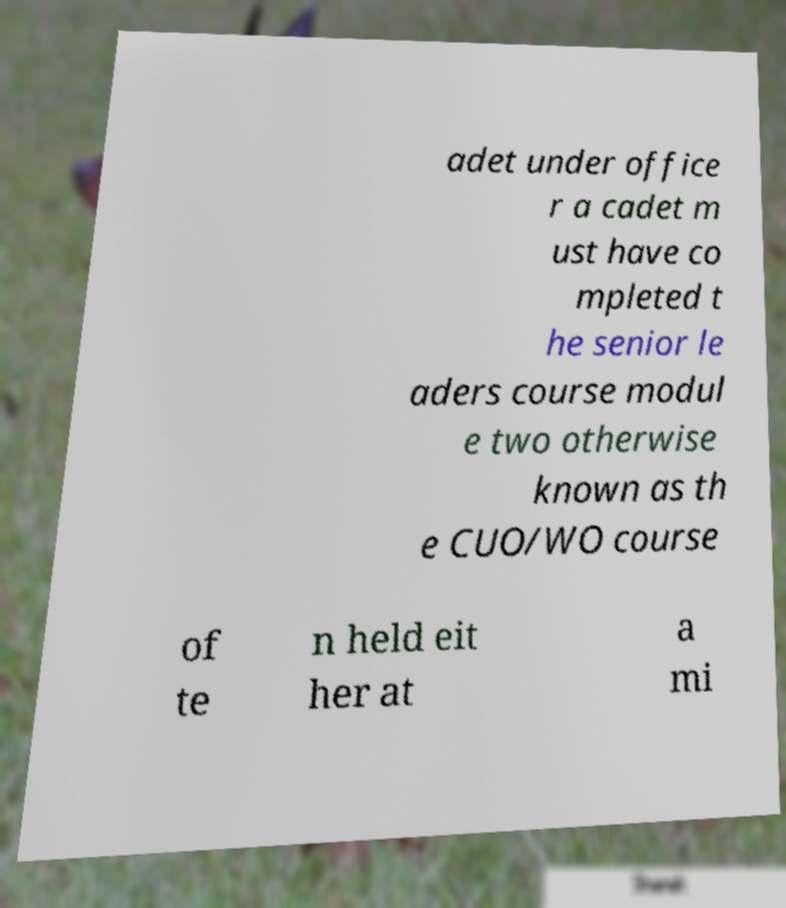What messages or text are displayed in this image? I need them in a readable, typed format. adet under office r a cadet m ust have co mpleted t he senior le aders course modul e two otherwise known as th e CUO/WO course of te n held eit her at a mi 